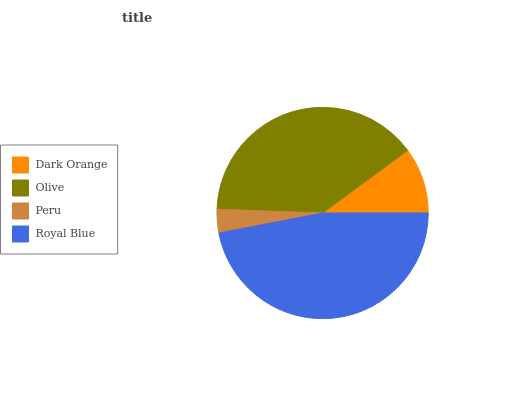Is Peru the minimum?
Answer yes or no. Yes. Is Royal Blue the maximum?
Answer yes or no. Yes. Is Olive the minimum?
Answer yes or no. No. Is Olive the maximum?
Answer yes or no. No. Is Olive greater than Dark Orange?
Answer yes or no. Yes. Is Dark Orange less than Olive?
Answer yes or no. Yes. Is Dark Orange greater than Olive?
Answer yes or no. No. Is Olive less than Dark Orange?
Answer yes or no. No. Is Olive the high median?
Answer yes or no. Yes. Is Dark Orange the low median?
Answer yes or no. Yes. Is Royal Blue the high median?
Answer yes or no. No. Is Royal Blue the low median?
Answer yes or no. No. 